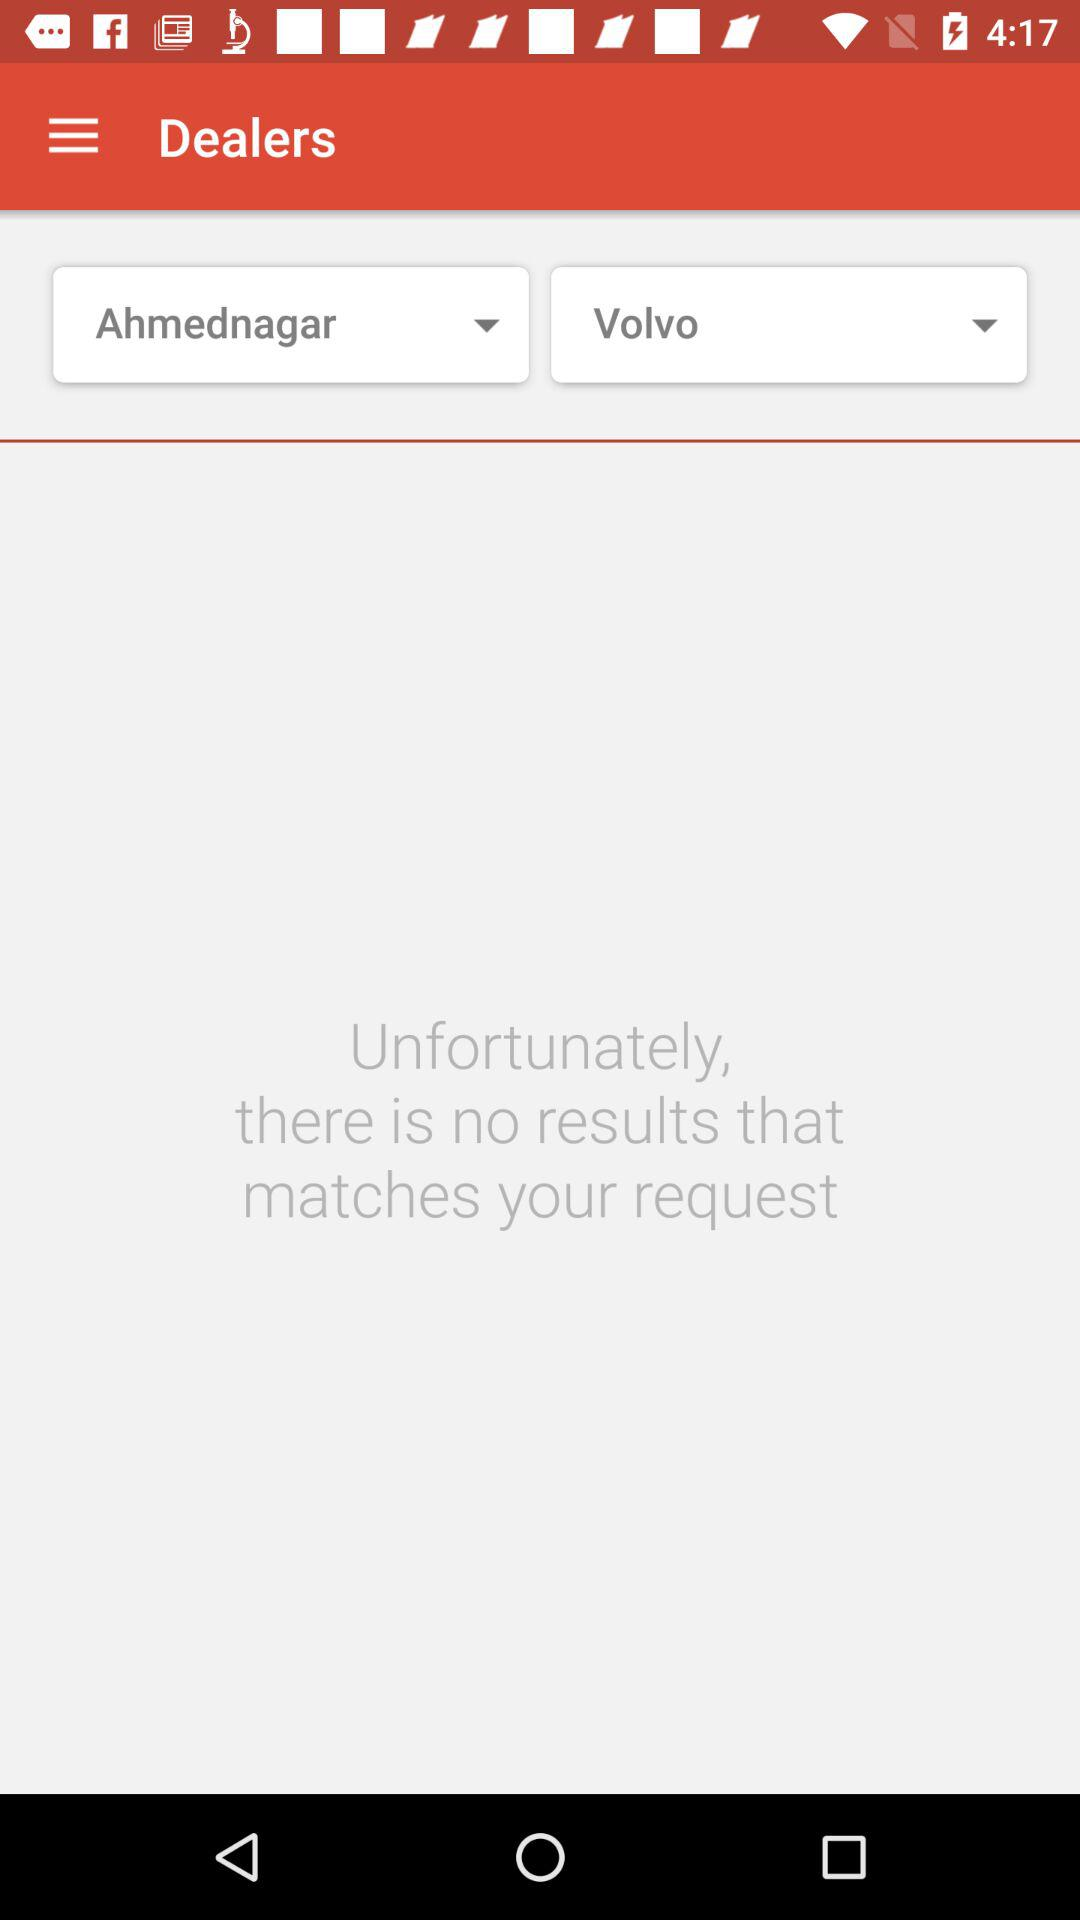Are there any matching results? There are no matching results. 